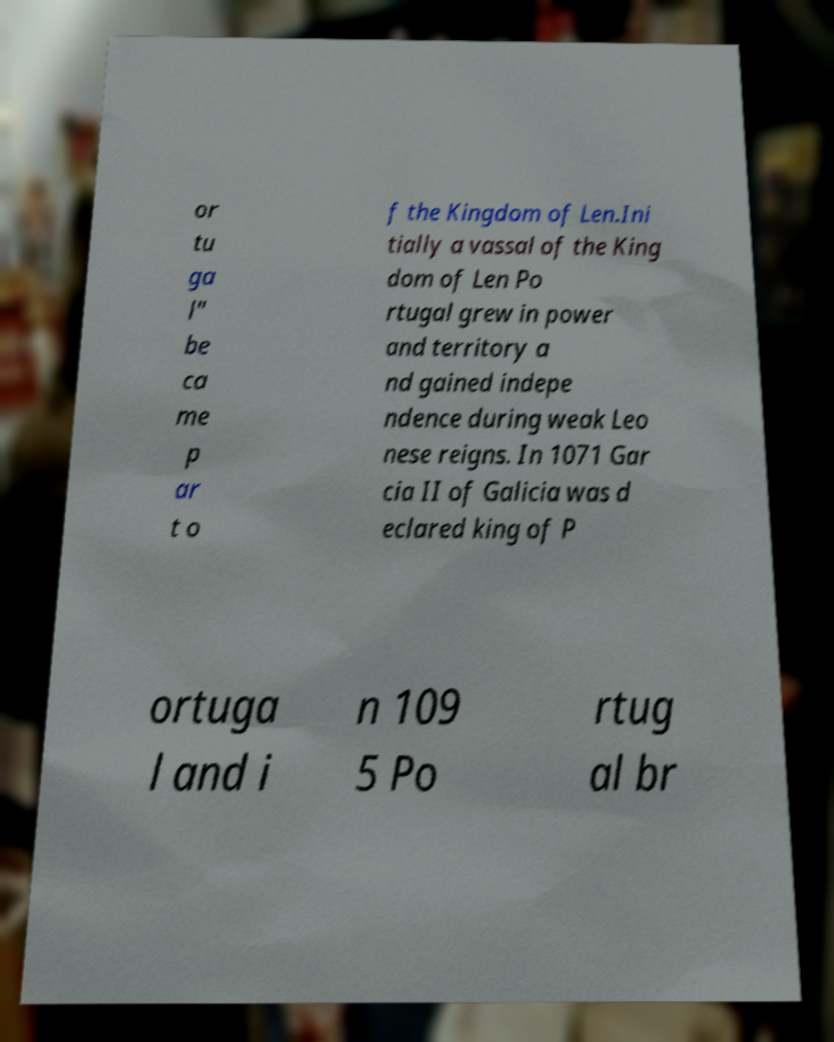Please read and relay the text visible in this image. What does it say? or tu ga l" be ca me p ar t o f the Kingdom of Len.Ini tially a vassal of the King dom of Len Po rtugal grew in power and territory a nd gained indepe ndence during weak Leo nese reigns. In 1071 Gar cia II of Galicia was d eclared king of P ortuga l and i n 109 5 Po rtug al br 